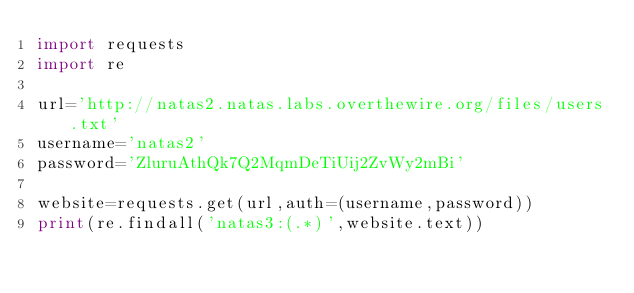<code> <loc_0><loc_0><loc_500><loc_500><_Python_>import requests
import re

url='http://natas2.natas.labs.overthewire.org/files/users.txt'
username='natas2'
password='ZluruAthQk7Q2MqmDeTiUij2ZvWy2mBi'

website=requests.get(url,auth=(username,password))
print(re.findall('natas3:(.*)',website.text))</code> 